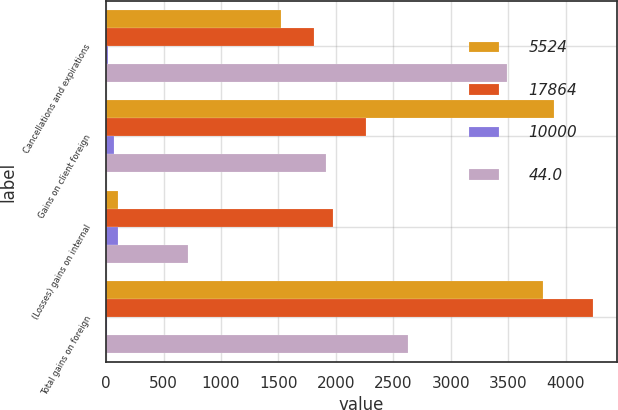<chart> <loc_0><loc_0><loc_500><loc_500><stacked_bar_chart><ecel><fcel>Cancellations and expirations<fcel>Gains on client foreign<fcel>(Losses) gains on internal<fcel>Total gains on foreign<nl><fcel>5524<fcel>1522<fcel>3901<fcel>103<fcel>3798<nl><fcel>17864<fcel>1806<fcel>2259<fcel>1973<fcel>4232<nl><fcel>10000<fcel>15.7<fcel>72.7<fcel>105.2<fcel>10.3<nl><fcel>44<fcel>3488<fcel>1914<fcel>710<fcel>2624<nl></chart> 